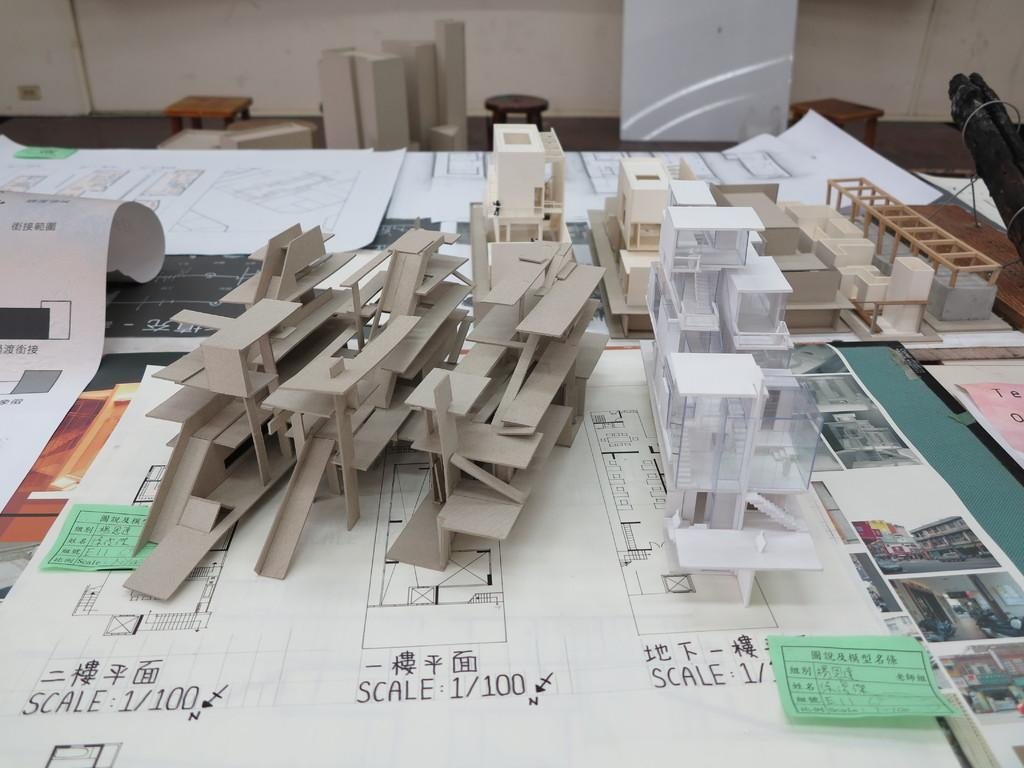<image>
Present a compact description of the photo's key features. Two tan-colored models of buildings are built to scale 1/100. 